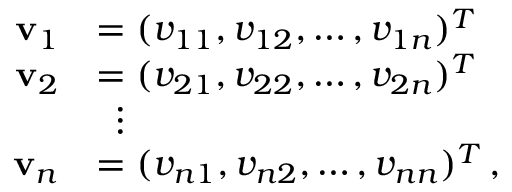Convert formula to latex. <formula><loc_0><loc_0><loc_500><loc_500>{ \begin{array} { r l } { v _ { 1 } } & { = ( v _ { 1 1 } , v _ { 1 2 } , \dots , v _ { 1 n } ) ^ { T } } \\ { v _ { 2 } } & { = ( v _ { 2 1 } , v _ { 2 2 } , \dots , v _ { 2 n } ) ^ { T } } \\ & { \, \vdots } \\ { v _ { n } } & { = ( v _ { n 1 } , v _ { n 2 } , \dots , v _ { n n } ) ^ { T } \, , } \end{array} }</formula> 